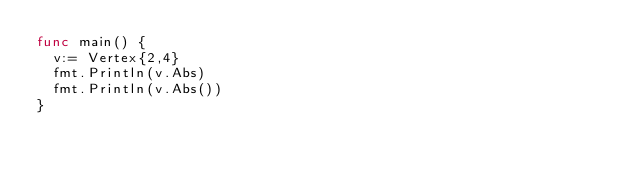Convert code to text. <code><loc_0><loc_0><loc_500><loc_500><_Go_>func main() {
	v:= Vertex{2,4}
	fmt.Println(v.Abs)
	fmt.Println(v.Abs())
}
</code> 